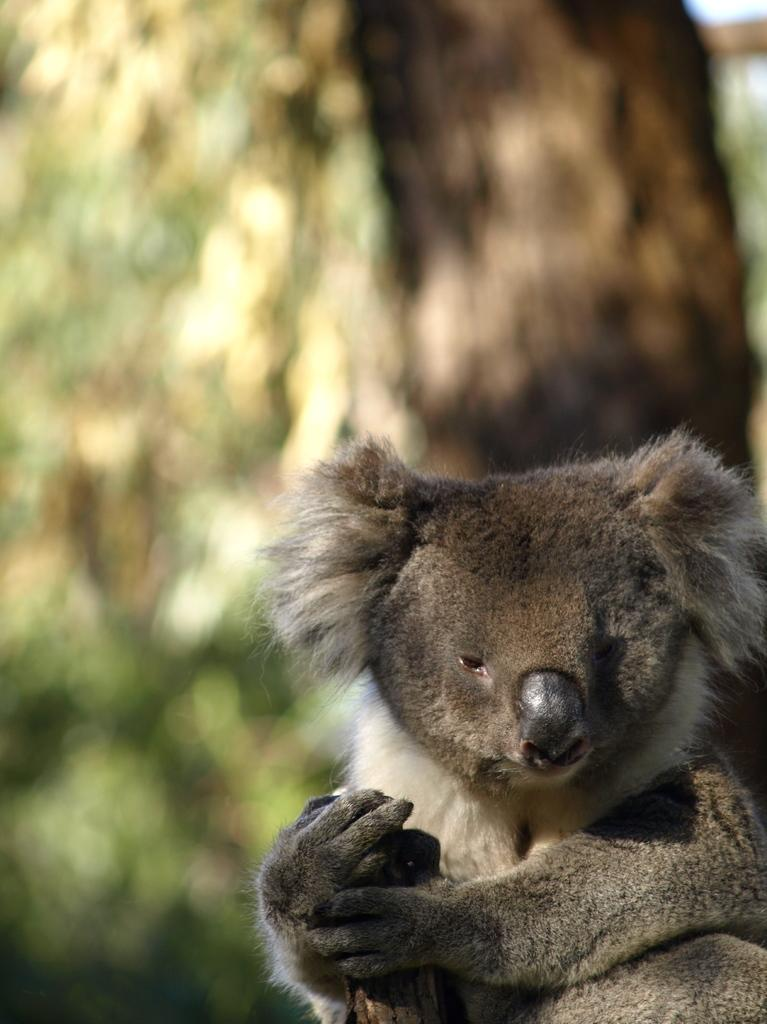What animal is the main subject of the image? There is a koala in the image. Where is the koala located in relation to the image? The koala is in the foreground. Can you describe the background of the image? The background of the image is blurred. What type of suit is the koala wearing on the page? There is no suit or page present in the image; it features a koala in the foreground with a blurred background. 